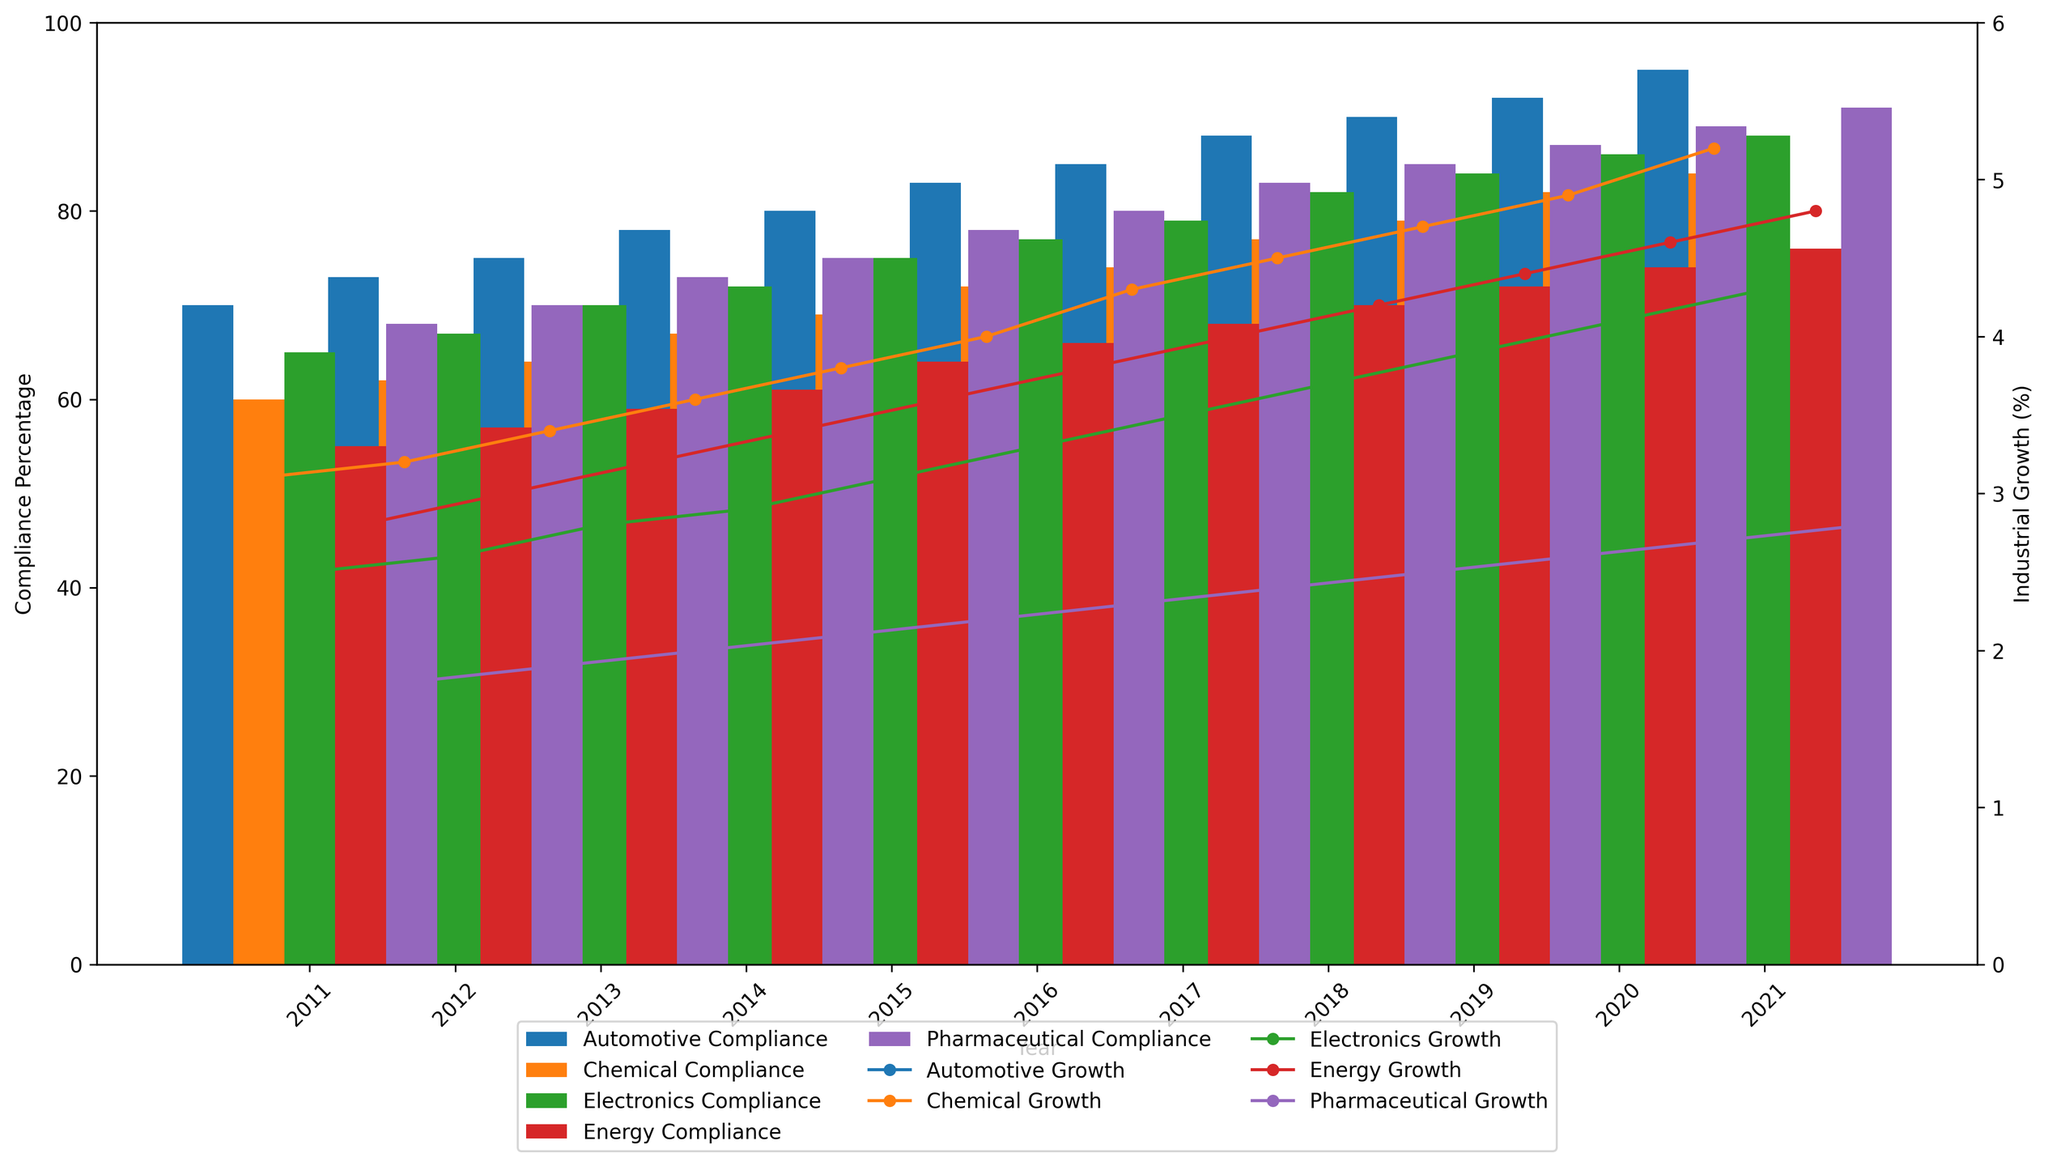Which industry has the highest compliance percentage in 2021? Look at the bar heights representing compliance in 2021 and identify the tallest bar.
Answer: Automotive Which year shows the largest growth in the Automotive industry? Compare the lengths of the lines representing industrial growth across all years in the Automotive industry and identify the longest line increment from one year to the next.
Answer: 2020 What is the difference in compliance between the Automotive and Energy sectors in 2015? Find the compliance percentage for both Automotive and Energy sectors in 2015 and subtract the latter from the former. (Automotive: 80, Energy: 64)
Answer: 16 Which industry had the smallest growth rate in 2011? Look at the heights of the growth lines for each industry in 2011 and identify the shortest line.
Answer: Energy Is there any year where the compliance percentage for the Electronics sector is equal to the growth rate of the Energy sector? Compare the compliance percentages of the Electronics sector and the growth rates of the Energy sector across all years. Look for any matching values.
Answer: No On average, which industry had a higher compliance percentage between 2015 and 2020, Chemical or Pharmaceutical? Calculate the average compliance percentage for both industries between 2015 and 2020 and compare. (Chemical average: (69+72+74+77+79+82)/6, Pharmaceutical average: (78+80+83+85+87+89)/6)
Answer: Pharmaceutical What is the percentage increase in compliance for the Chemical sector from 2011 to 2021? Calculate the difference in compliance percentage for the Chemical sector from 2011 to 2021 and divide by the 2011 value, then multiply by 100. ((84 - 60) / 60) * 100
Answer: 40% Which industry experienced a higher growth rate in 2019, Electronics or Chemical? Compare the lengths of the growth lines for Electronics and Chemical industries in 2019 and identify which is taller.
Answer: Electronics What is the total industrial growth for the Pharmaceutical industry from 2011 to 2021? Sum the growth percentages for the Pharmaceutical industry across all years from 2011 to 2021. 3.0+3.1+3.3+3.5+3.7+3.9+4.1+4.3+4.5+4.7+4.9
Answer: 42.0 